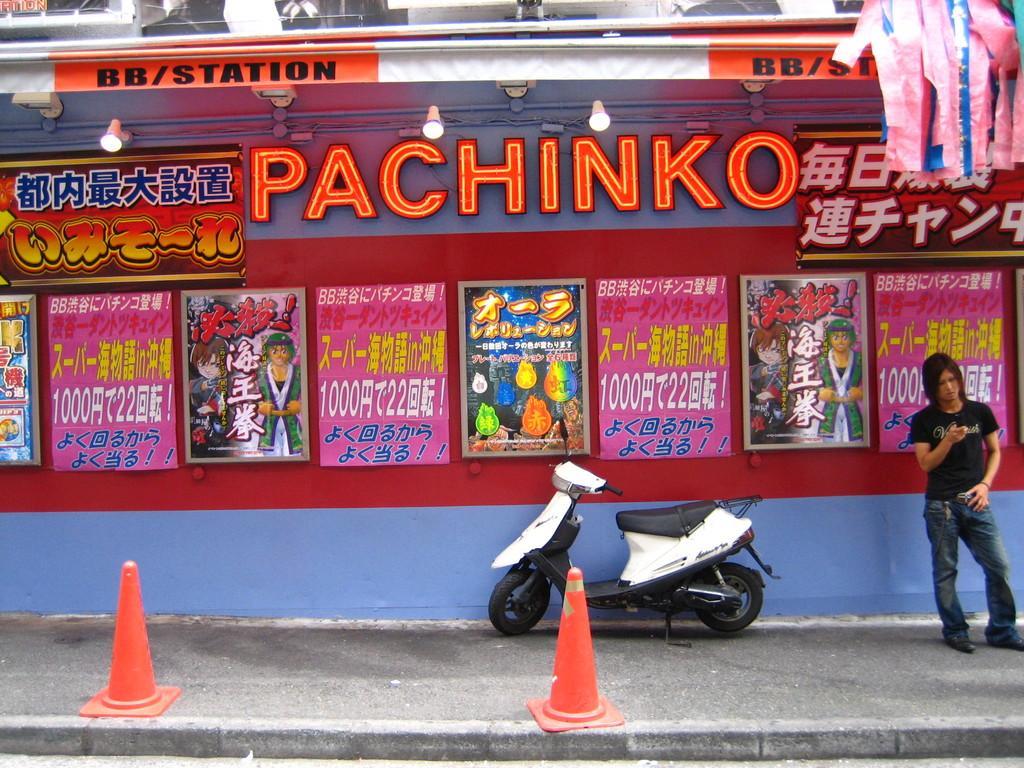Describe this image in one or two sentences. In this image we can see a person holding an object in his hand is standing on the ground. In the foreground of the image we can see a motorcycle and some cones placed on the ground. In the center of the image we can see some photo frames and sign boards with text. In the background, we can see some lights and some ribbons. 